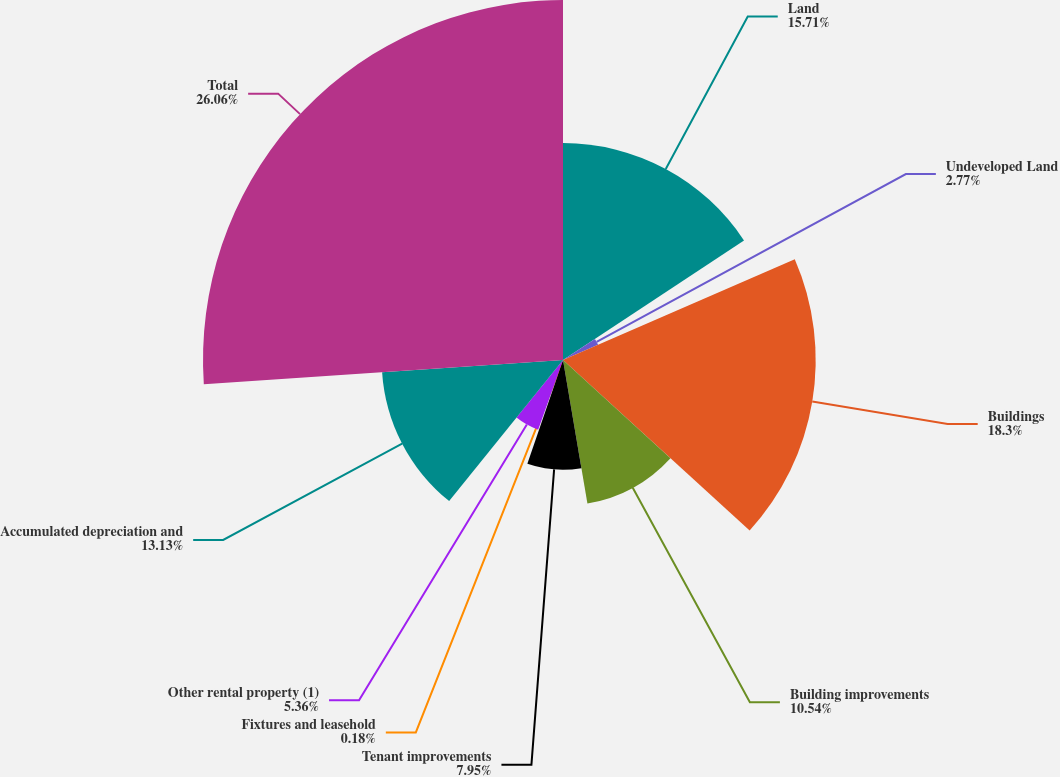<chart> <loc_0><loc_0><loc_500><loc_500><pie_chart><fcel>Land<fcel>Undeveloped Land<fcel>Buildings<fcel>Building improvements<fcel>Tenant improvements<fcel>Fixtures and leasehold<fcel>Other rental property (1)<fcel>Accumulated depreciation and<fcel>Total<nl><fcel>15.71%<fcel>2.77%<fcel>18.3%<fcel>10.54%<fcel>7.95%<fcel>0.18%<fcel>5.36%<fcel>13.13%<fcel>26.07%<nl></chart> 